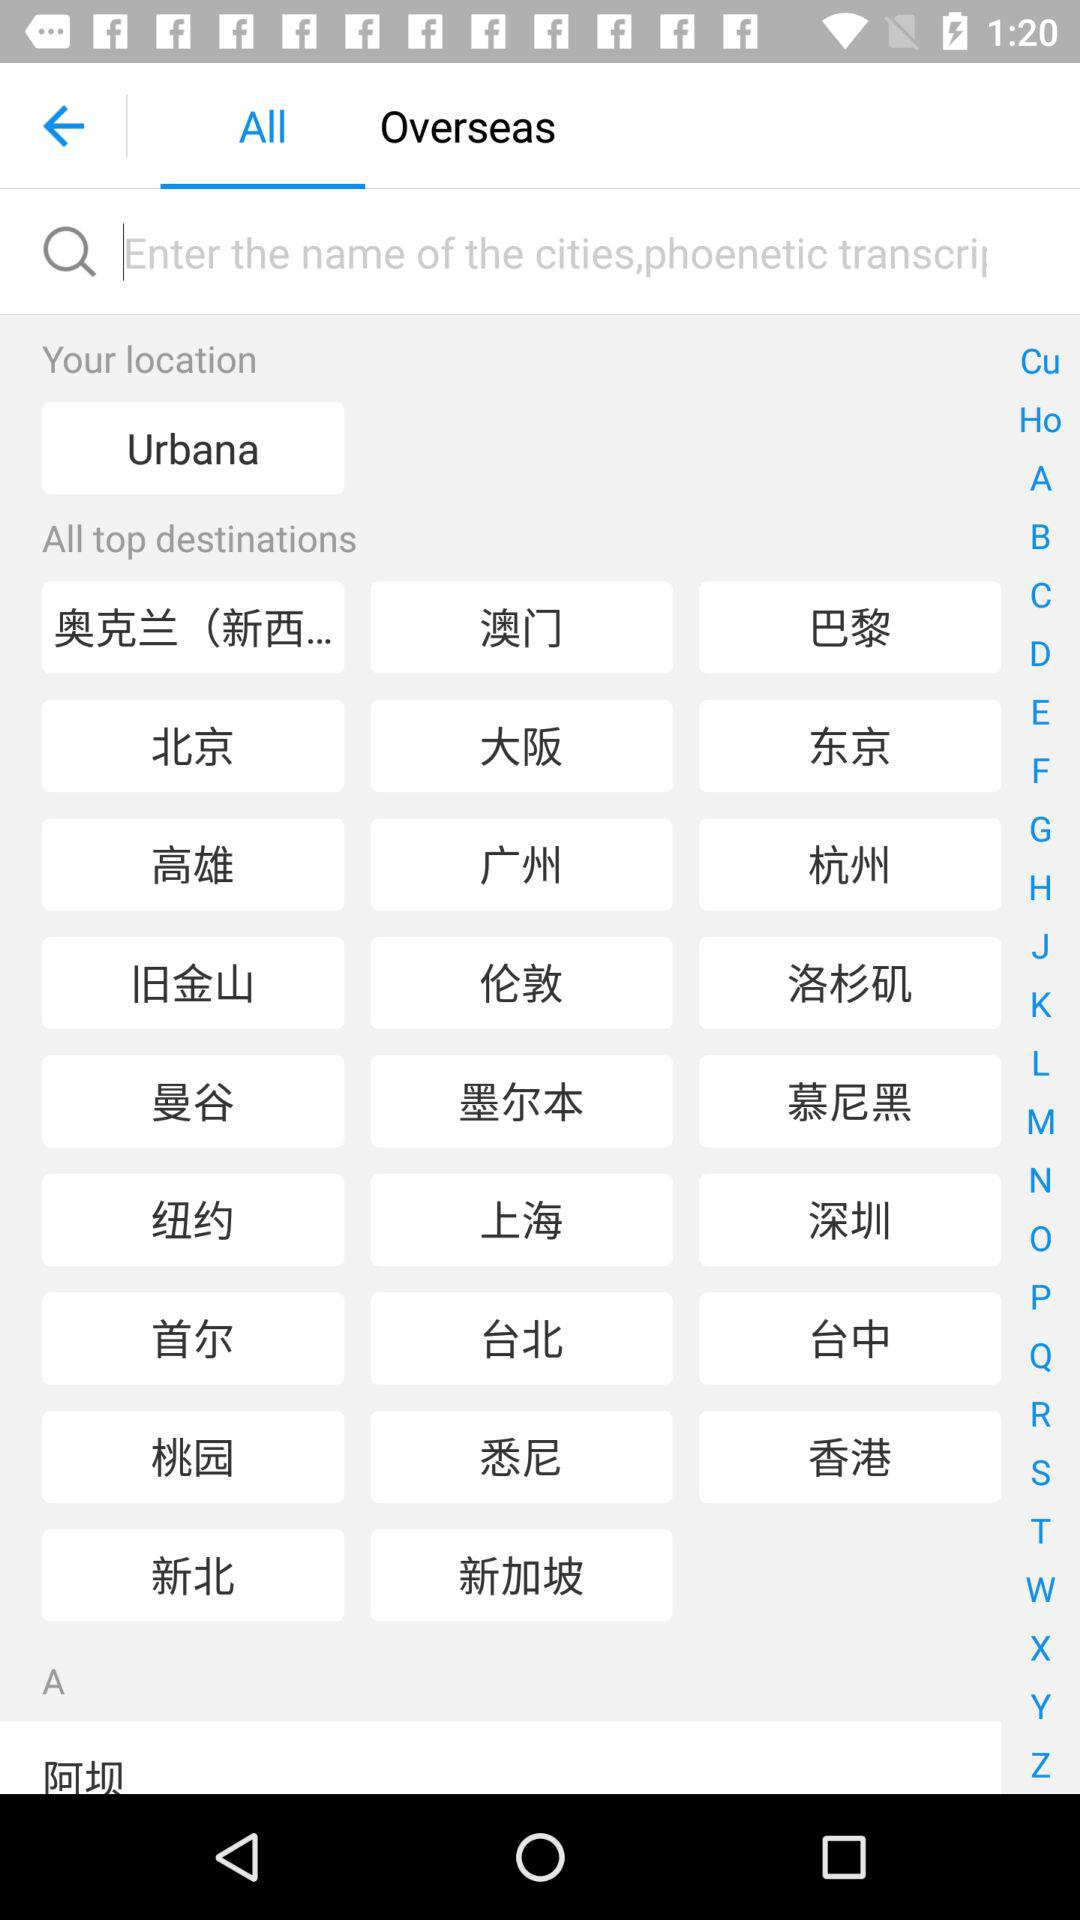Which tab is selected? The selected tab is "All". 